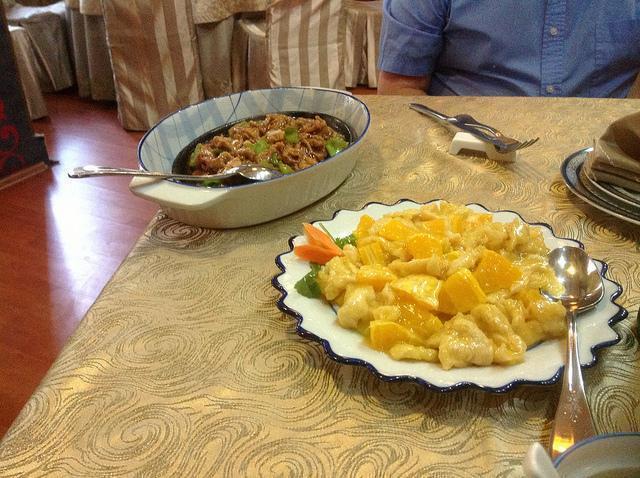What utensil is missing from this table?
Choose the correct response and explain in the format: 'Answer: answer
Rationale: rationale.'
Options: Knife, fork, plate, spoon. Answer: knife.
Rationale: There are forks and spoons. 